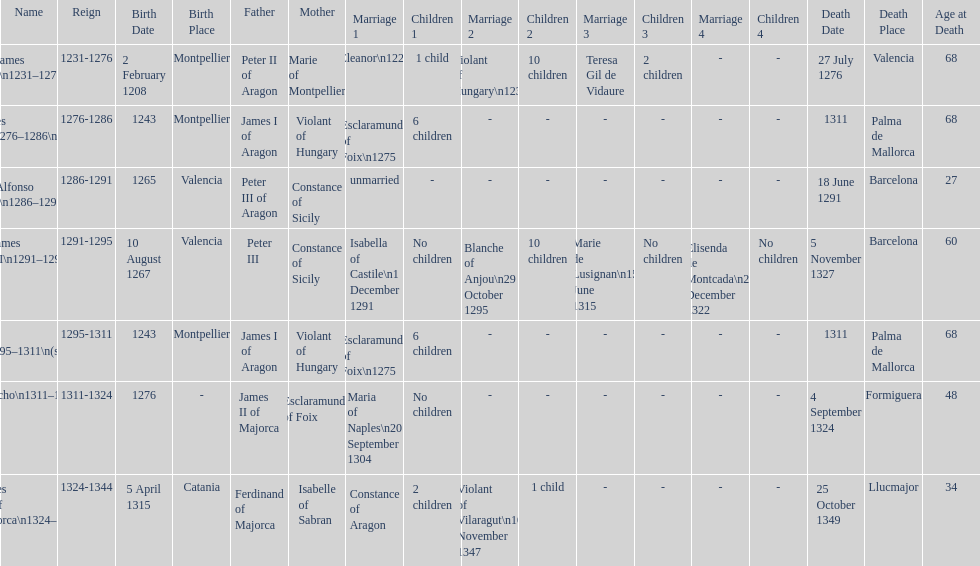Was james iii or sancho born in the year 1276? Sancho. Could you parse the entire table as a dict? {'header': ['Name', 'Reign', 'Birth Date', 'Birth Place', 'Father', 'Mother', 'Marriage 1', 'Children 1', 'Marriage 2', 'Children 2', 'Marriage 3', 'Children 3', 'Marriage 4', 'Children 4', 'Death Date', 'Death Place', 'Age at Death'], 'rows': [['James I\\n1231–1276', '1231-1276', '2 February 1208', 'Montpellier', 'Peter II of Aragon', 'Marie of Montpellier', 'Eleanor\\n1221', '1 child', 'Violant of Hungary\\n1235', '10 children', 'Teresa Gil de Vidaure', '2 children', '-', '-', '27 July 1276', 'Valencia', '68'], ['James II\\n1276–1286\\n(first rule)', '1276-1286', '1243', 'Montpellier', 'James I of Aragon', 'Violant of Hungary', 'Esclaramunda of Foix\\n1275', '6 children', '-', '-', '-', '-', '-', '-', '1311', 'Palma de Mallorca', '68'], ['Alfonso I\\n1286–1291', '1286-1291', '1265', 'Valencia', 'Peter III of Aragon', 'Constance of Sicily', 'unmarried', '-', '-', '-', '-', '-', '-', '-', '18 June 1291', 'Barcelona', '27'], ['James III\\n1291–1295', '1291-1295', '10 August 1267', 'Valencia', 'Peter III', 'Constance of Sicily', 'Isabella of Castile\\n1 December 1291', 'No children', 'Blanche of Anjou\\n29 October 1295', '10 children', 'Marie de Lusignan\\n15 June 1315', 'No children', 'Elisenda de Montcada\\n25 December 1322', 'No children', '5 November 1327', 'Barcelona', '60'], ['James II\\n1295–1311\\n(second rule)', '1295-1311', '1243', 'Montpellier', 'James I of Aragon', 'Violant of Hungary', 'Esclaramunda of Foix\\n1275', '6 children', '-', '-', '-', '-', '-', '-', '1311', 'Palma de Mallorca', '68'], ['Sancho\\n1311–1324', '1311-1324', '1276', '-', 'James II of Majorca', 'Esclaramunda of Foix', 'Maria of Naples\\n20 September 1304', 'No children', '-', '-', '-', '-', '-', '-', '4 September 1324', 'Formiguera', '48'], ['James III of Majorca\\n1324–1344', '1324-1344', '5 April 1315', 'Catania', 'Ferdinand of Majorca', 'Isabelle of Sabran', 'Constance of Aragon', '2 children', 'Violant of Vilaragut\\n10 November 1347', '1 child', '-', '-', '-', '-', '25 October 1349', 'Llucmajor', '34']]} 